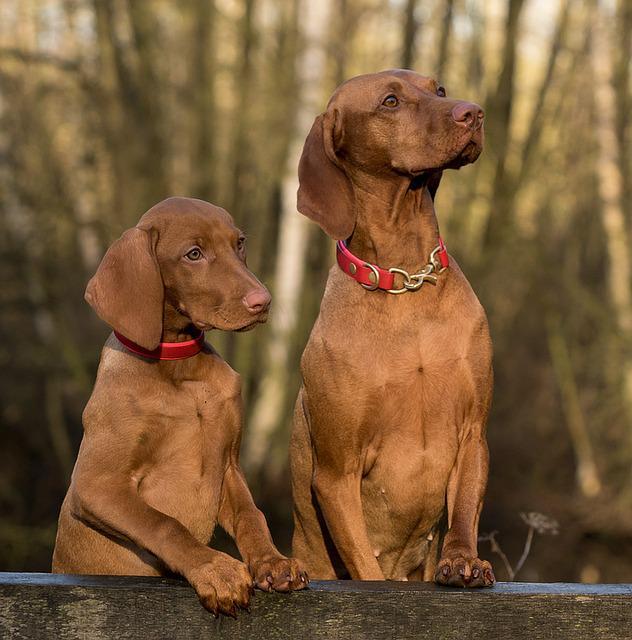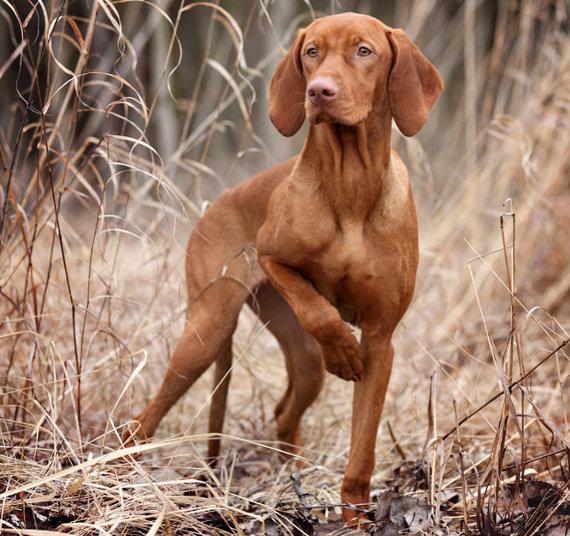The first image is the image on the left, the second image is the image on the right. Considering the images on both sides, is "Each image shows a single dog that is outside and wearing a collar." valid? Answer yes or no. No. 